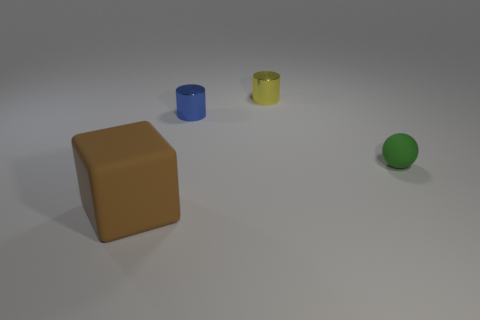Are there any other things that have the same size as the rubber block?
Give a very brief answer. No. Is there any other thing that has the same shape as the big brown object?
Make the answer very short. No. Are there fewer green matte things left of the small blue cylinder than shiny cylinders behind the small green rubber sphere?
Keep it short and to the point. Yes. Do the big object and the blue metal thing have the same shape?
Your answer should be compact. No. How many green metallic cubes have the same size as the green rubber object?
Give a very brief answer. 0. Are there fewer tiny blue metal things that are on the right side of the small blue cylinder than large purple cubes?
Your response must be concise. No. There is a rubber object on the left side of the shiny cylinder in front of the yellow metallic object; what is its size?
Keep it short and to the point. Large. What number of objects are either large cyan shiny cylinders or big brown blocks?
Your answer should be very brief. 1. Are there any metal things that have the same color as the rubber cube?
Provide a succinct answer. No. Is the number of objects less than the number of small cyan matte objects?
Your answer should be very brief. No. 